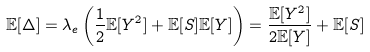<formula> <loc_0><loc_0><loc_500><loc_500>\mathbb { E } [ \Delta ] & = \lambda _ { e } \left ( \frac { 1 } { 2 } \mathbb { E } [ Y ^ { 2 } ] + \mathbb { E } [ S ] \mathbb { E } [ Y ] \right ) = \frac { \mathbb { E } [ Y ^ { 2 } ] } { 2 \mathbb { E } [ Y ] } + \mathbb { E } [ S ]</formula> 